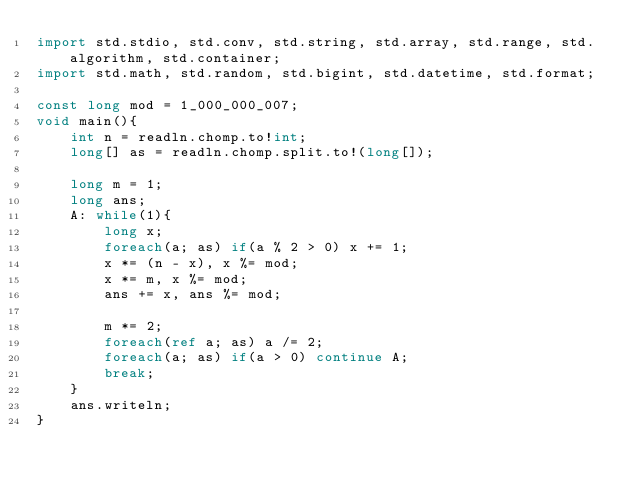<code> <loc_0><loc_0><loc_500><loc_500><_D_>import std.stdio, std.conv, std.string, std.array, std.range, std.algorithm, std.container;
import std.math, std.random, std.bigint, std.datetime, std.format;

const long mod = 1_000_000_007;
void main(){
	int n = readln.chomp.to!int;
	long[] as = readln.chomp.split.to!(long[]);

	long m = 1;
	long ans;
	A: while(1){
		long x;
		foreach(a; as) if(a % 2 > 0) x += 1;
		x *= (n - x), x %= mod;
		x *= m, x %= mod;
		ans += x, ans %= mod;

		m *= 2;
		foreach(ref a; as) a /= 2;
		foreach(a; as) if(a > 0) continue A;
		break;
	}
	ans.writeln;
}
</code> 